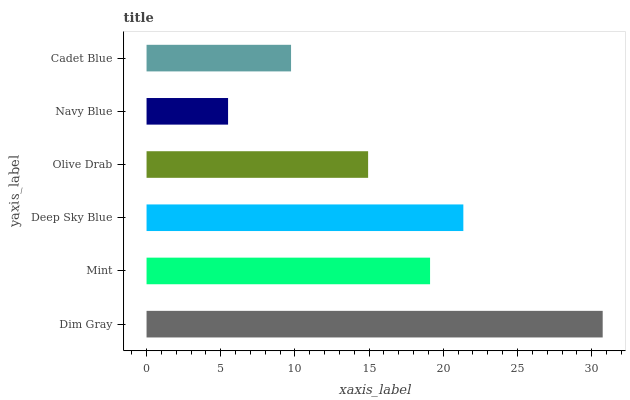Is Navy Blue the minimum?
Answer yes or no. Yes. Is Dim Gray the maximum?
Answer yes or no. Yes. Is Mint the minimum?
Answer yes or no. No. Is Mint the maximum?
Answer yes or no. No. Is Dim Gray greater than Mint?
Answer yes or no. Yes. Is Mint less than Dim Gray?
Answer yes or no. Yes. Is Mint greater than Dim Gray?
Answer yes or no. No. Is Dim Gray less than Mint?
Answer yes or no. No. Is Mint the high median?
Answer yes or no. Yes. Is Olive Drab the low median?
Answer yes or no. Yes. Is Deep Sky Blue the high median?
Answer yes or no. No. Is Navy Blue the low median?
Answer yes or no. No. 